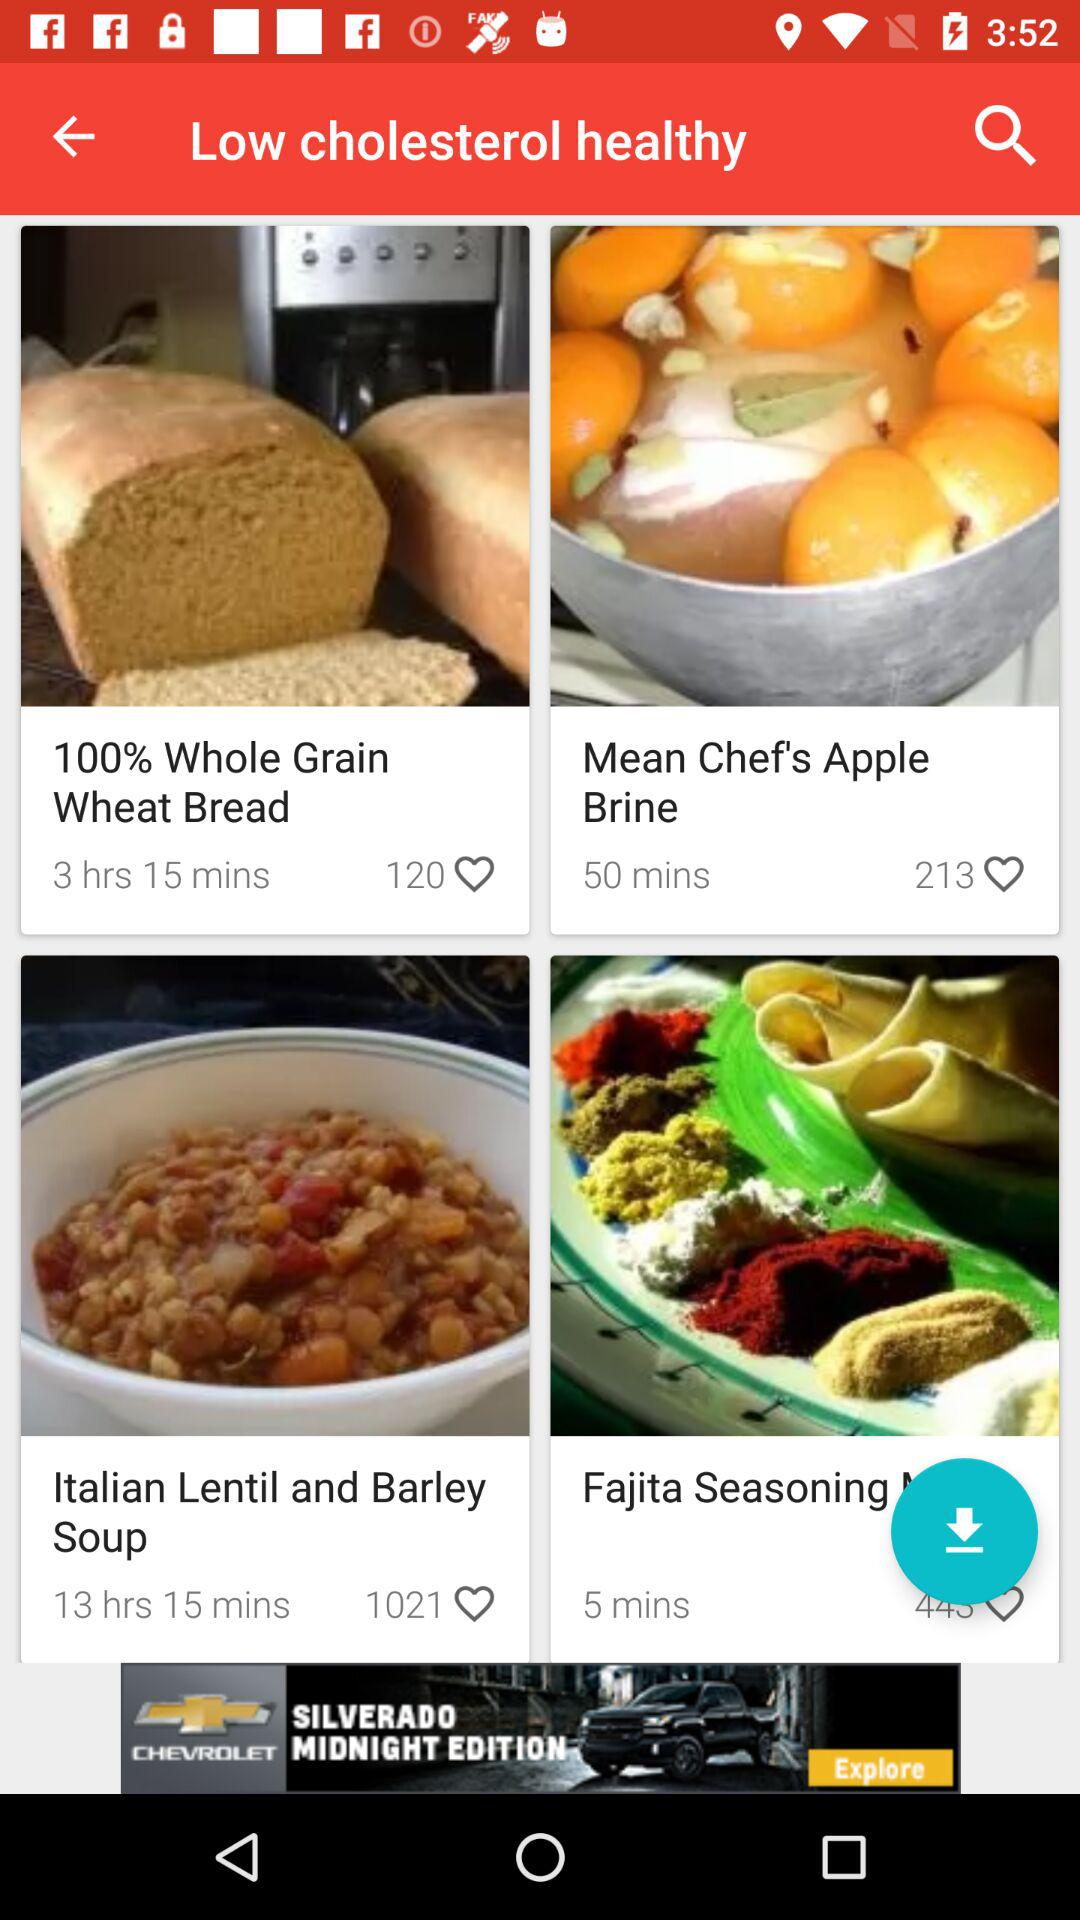What is the name of the dish? The names of the dishes are "100% Whole Grain Wheat Bread", "Mean Chef's Apple Brine" and "Italian Lentil and Barley Soup". 